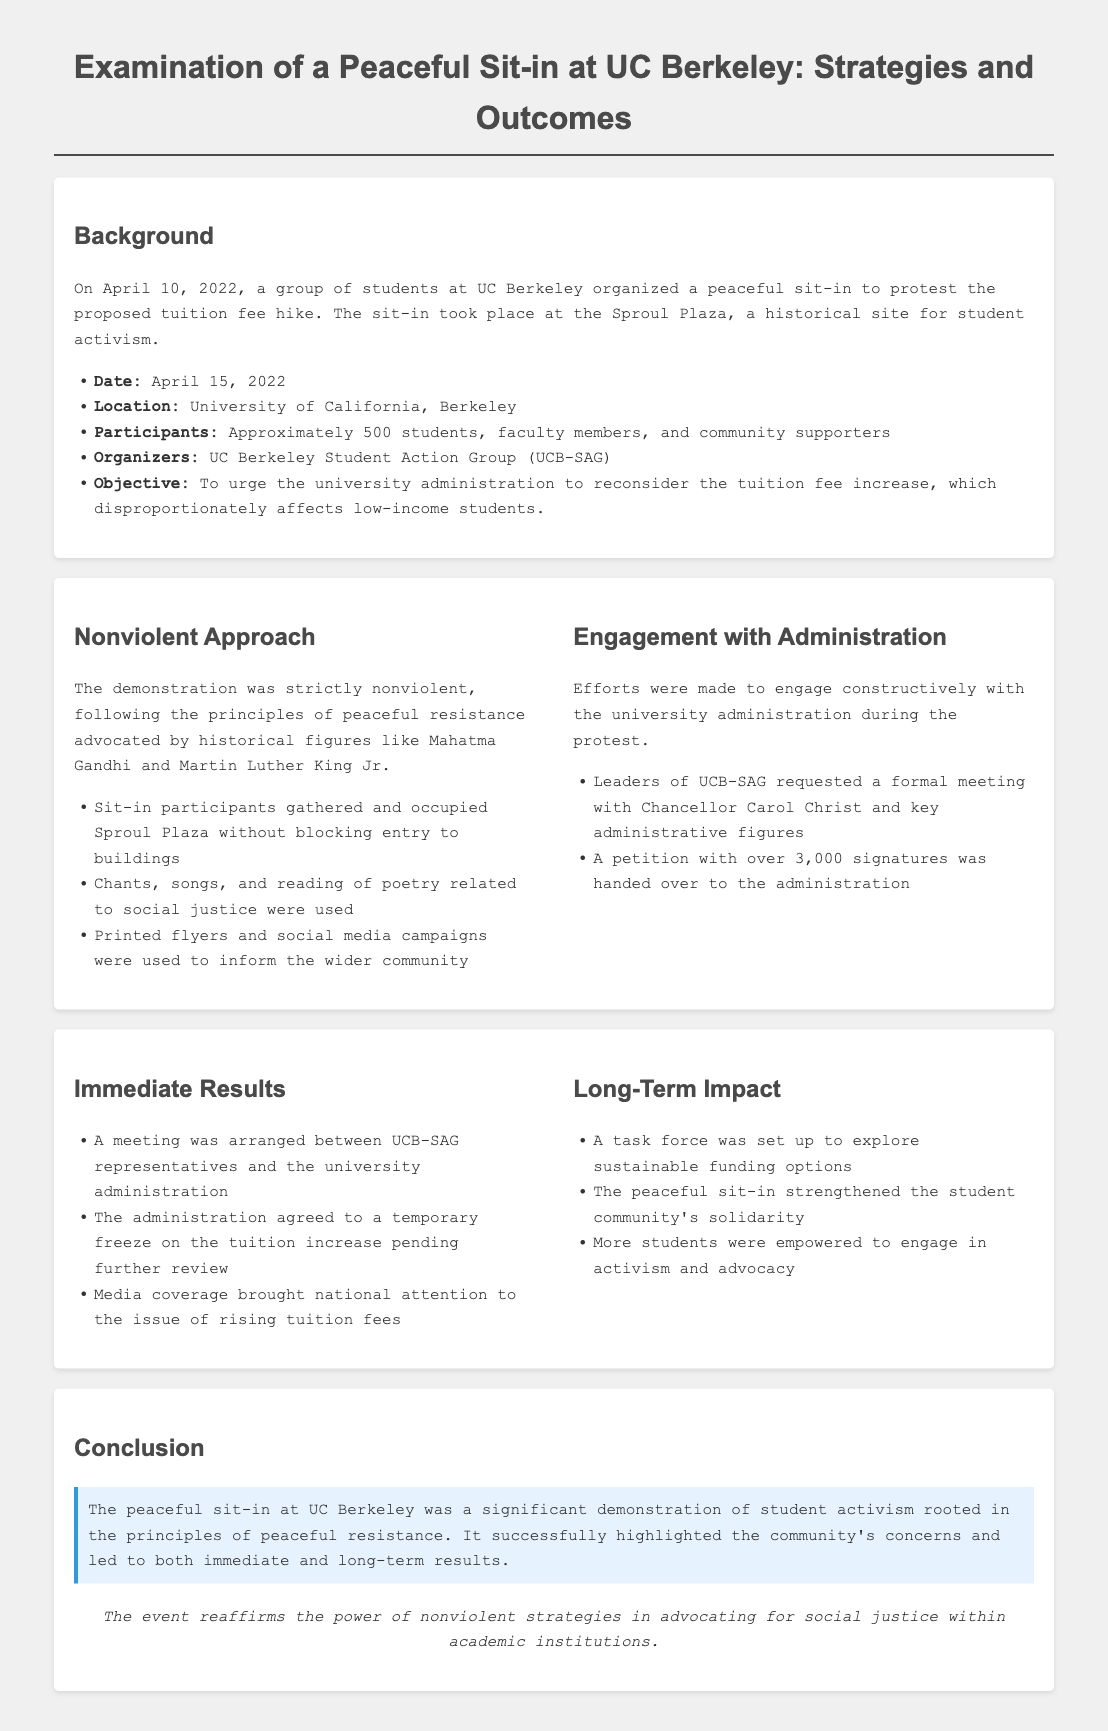What was the date of the sit-in? The date of the sit-in is specified in the document as April 10, 2022.
Answer: April 10, 2022 How many participants were involved in the sit-in? The document states that approximately 500 students, faculty members, and community supporters participated in the sit-in.
Answer: Approximately 500 What was the objective of the protest? The objective of the protest is clearly outlined in the document as urging the university administration to reconsider the tuition fee increase.
Answer: To urge the university administration to reconsider the tuition fee increase Who organized the sit-in? The organizers of the sit-in are identified in the document as the UC Berkeley Student Action Group (UCB-SAG).
Answer: UC Berkeley Student Action Group (UCB-SAG) What immediate result followed the sit-in? One immediate result mentioned is that a meeting was arranged between UCB-SAG representatives and the university administration.
Answer: A meeting was arranged What long-term impact did the sit-in have on the student community? The document highlights that the peaceful sit-in strengthened the student community's solidarity as a long-term impact.
Answer: Strengthened the student community's solidarity What nonviolent strategy was used during the sit-in? The document details that participants gathered and occupied Sproul Plaza without blocking entry to buildings as a nonviolent strategy.
Answer: Occupied Sproul Plaza without blocking entry How many signatures were collected for the petition? According to the document, the petition handed over to the administration had over 3,000 signatures collected.
Answer: Over 3,000 signatures What is the overall conclusion drawn in the report? The conclusion emphasizes the significant demonstration of student activism and the power of nonviolent strategies in advocating for social justice.
Answer: Significant demonstration of student activism 